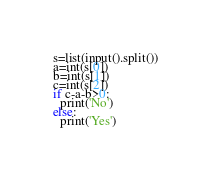Convert code to text. <code><loc_0><loc_0><loc_500><loc_500><_Python_>s=list(input().split())
a=int(s[0])
b=int(s[1])
c=int(s[2])
if c-a-b>0:
  print('No')
else:
  print('Yes')</code> 